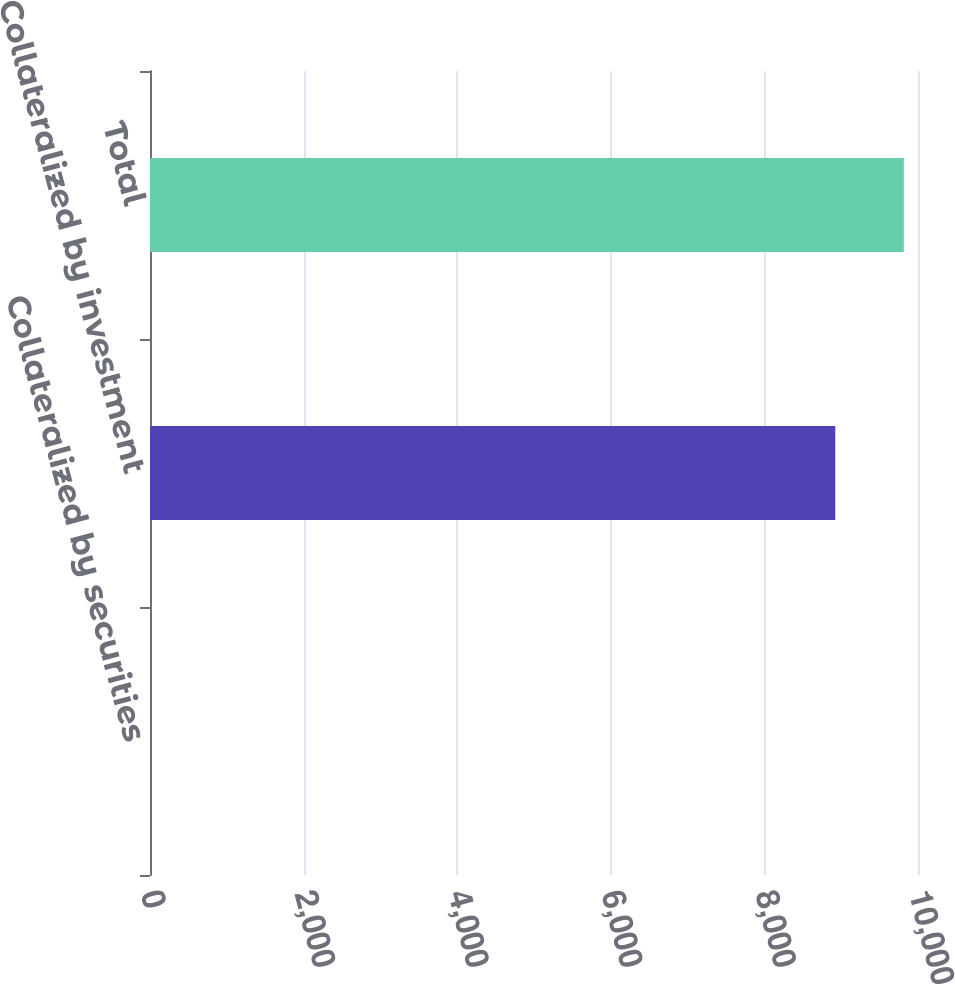Convert chart. <chart><loc_0><loc_0><loc_500><loc_500><bar_chart><fcel>Collateralized by securities<fcel>Collateralized by investment<fcel>Total<nl><fcel>2<fcel>8923<fcel>9815.3<nl></chart> 